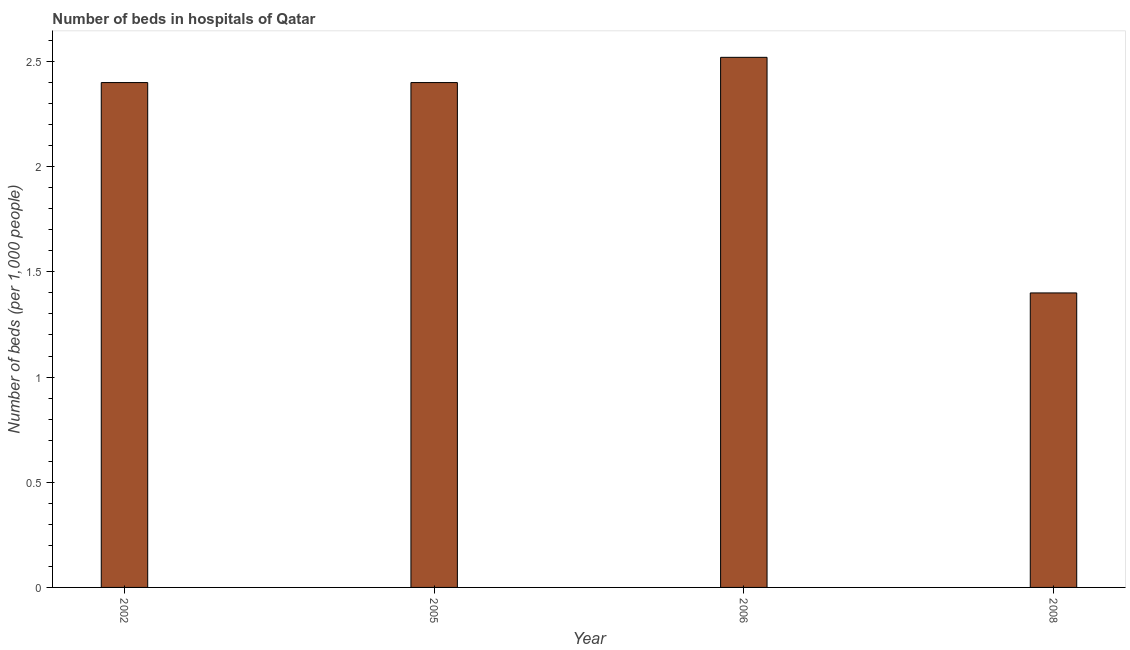Does the graph contain any zero values?
Your answer should be compact. No. Does the graph contain grids?
Offer a very short reply. No. What is the title of the graph?
Your answer should be very brief. Number of beds in hospitals of Qatar. What is the label or title of the Y-axis?
Your answer should be compact. Number of beds (per 1,0 people). What is the number of hospital beds in 2006?
Give a very brief answer. 2.52. Across all years, what is the maximum number of hospital beds?
Offer a very short reply. 2.52. Across all years, what is the minimum number of hospital beds?
Ensure brevity in your answer.  1.4. What is the sum of the number of hospital beds?
Your answer should be very brief. 8.72. What is the difference between the number of hospital beds in 2002 and 2008?
Give a very brief answer. 1. What is the average number of hospital beds per year?
Offer a terse response. 2.18. What is the median number of hospital beds?
Keep it short and to the point. 2.4. Is the difference between the number of hospital beds in 2002 and 2008 greater than the difference between any two years?
Provide a short and direct response. No. What is the difference between the highest and the second highest number of hospital beds?
Make the answer very short. 0.12. What is the difference between the highest and the lowest number of hospital beds?
Give a very brief answer. 1.12. In how many years, is the number of hospital beds greater than the average number of hospital beds taken over all years?
Make the answer very short. 3. Are the values on the major ticks of Y-axis written in scientific E-notation?
Give a very brief answer. No. What is the Number of beds (per 1,000 people) of 2002?
Ensure brevity in your answer.  2.4. What is the Number of beds (per 1,000 people) of 2005?
Your answer should be compact. 2.4. What is the Number of beds (per 1,000 people) in 2006?
Offer a very short reply. 2.52. What is the Number of beds (per 1,000 people) of 2008?
Keep it short and to the point. 1.4. What is the difference between the Number of beds (per 1,000 people) in 2002 and 2006?
Your response must be concise. -0.12. What is the difference between the Number of beds (per 1,000 people) in 2002 and 2008?
Make the answer very short. 1. What is the difference between the Number of beds (per 1,000 people) in 2005 and 2006?
Ensure brevity in your answer.  -0.12. What is the difference between the Number of beds (per 1,000 people) in 2006 and 2008?
Make the answer very short. 1.12. What is the ratio of the Number of beds (per 1,000 people) in 2002 to that in 2005?
Give a very brief answer. 1. What is the ratio of the Number of beds (per 1,000 people) in 2002 to that in 2008?
Ensure brevity in your answer.  1.71. What is the ratio of the Number of beds (per 1,000 people) in 2005 to that in 2006?
Offer a very short reply. 0.95. What is the ratio of the Number of beds (per 1,000 people) in 2005 to that in 2008?
Offer a very short reply. 1.71. What is the ratio of the Number of beds (per 1,000 people) in 2006 to that in 2008?
Your answer should be very brief. 1.8. 